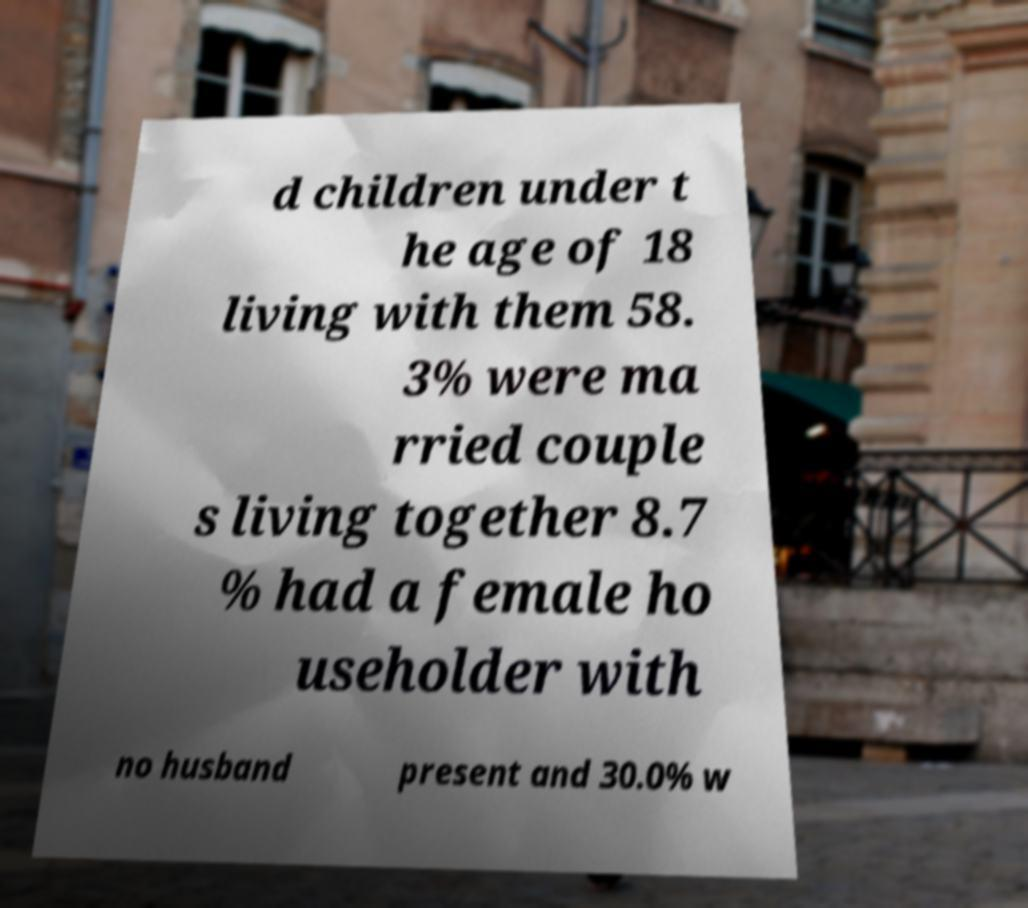There's text embedded in this image that I need extracted. Can you transcribe it verbatim? d children under t he age of 18 living with them 58. 3% were ma rried couple s living together 8.7 % had a female ho useholder with no husband present and 30.0% w 